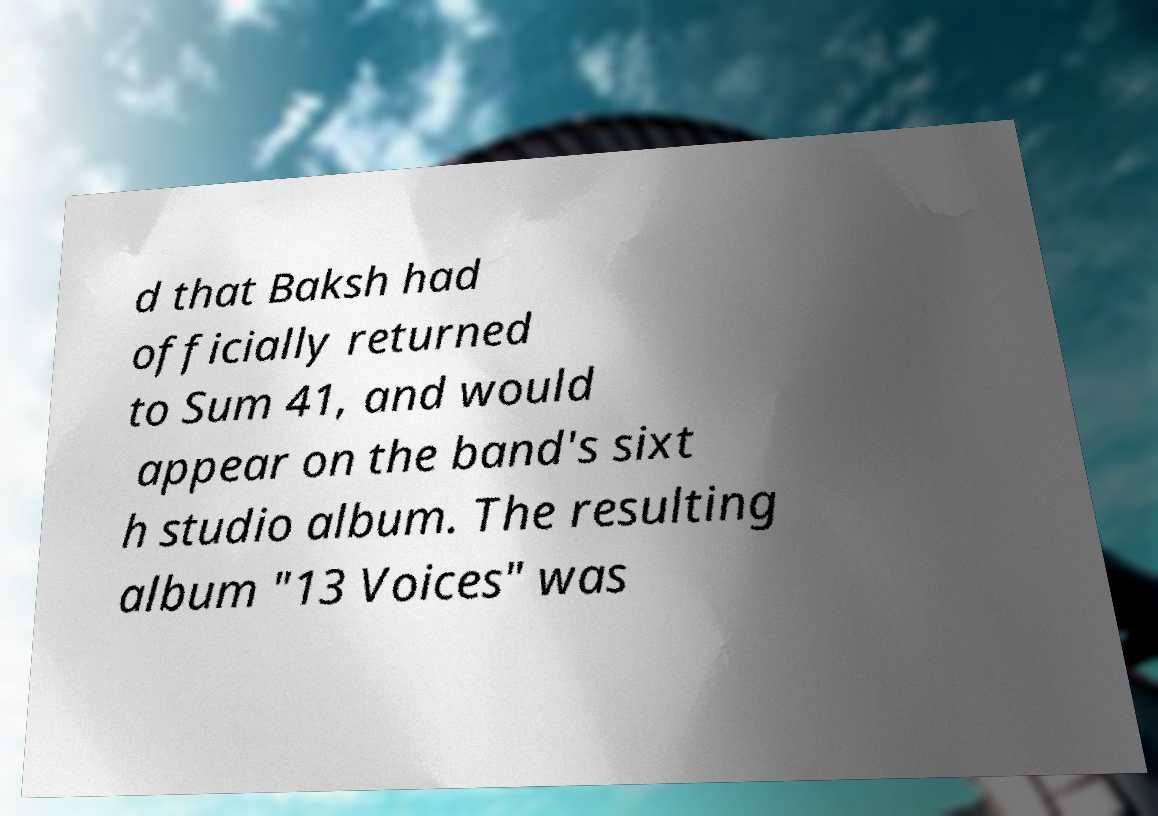Please read and relay the text visible in this image. What does it say? d that Baksh had officially returned to Sum 41, and would appear on the band's sixt h studio album. The resulting album "13 Voices" was 